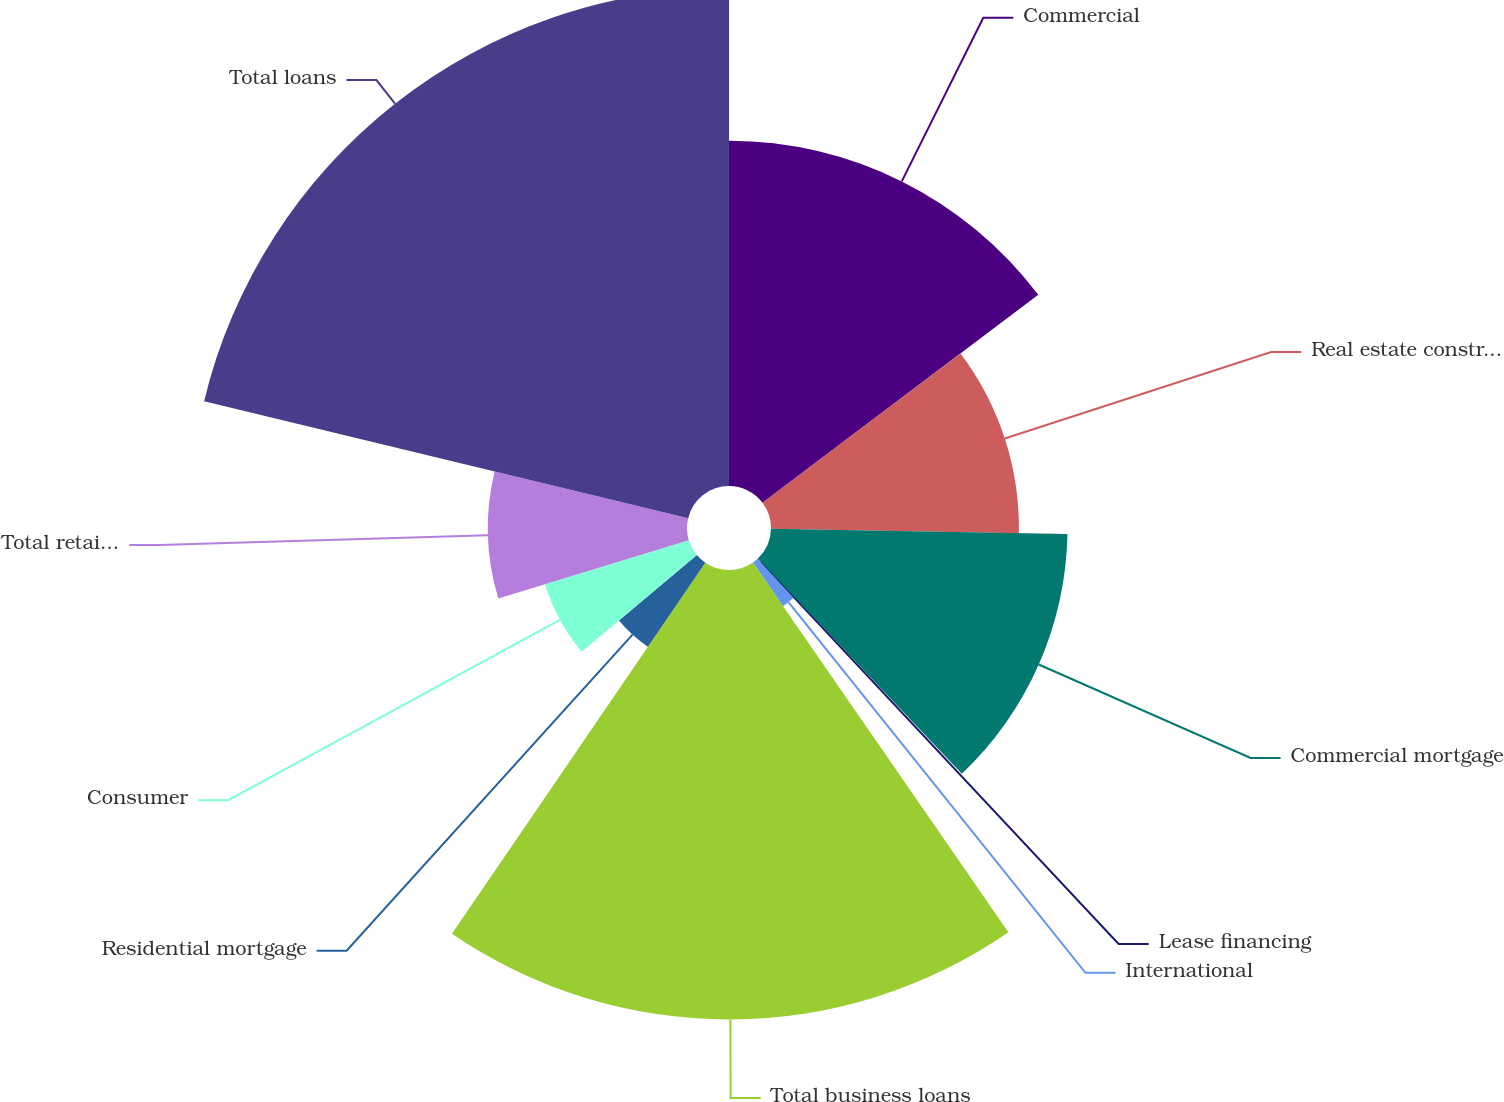Convert chart. <chart><loc_0><loc_0><loc_500><loc_500><pie_chart><fcel>Commercial<fcel>Real estate construction<fcel>Commercial mortgage<fcel>Lease financing<fcel>International<fcel>Total business loans<fcel>Residential mortgage<fcel>Consumer<fcel>Total retail loans<fcel>Total loans<nl><fcel>14.72%<fcel>10.57%<fcel>12.64%<fcel>0.19%<fcel>2.26%<fcel>19.16%<fcel>4.34%<fcel>6.41%<fcel>8.49%<fcel>21.23%<nl></chart> 